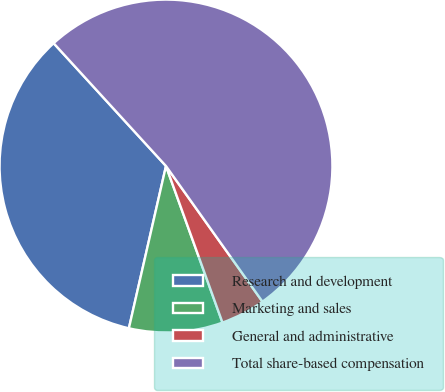<chart> <loc_0><loc_0><loc_500><loc_500><pie_chart><fcel>Research and development<fcel>Marketing and sales<fcel>General and administrative<fcel>Total share-based compensation<nl><fcel>34.63%<fcel>9.09%<fcel>4.33%<fcel>51.95%<nl></chart> 